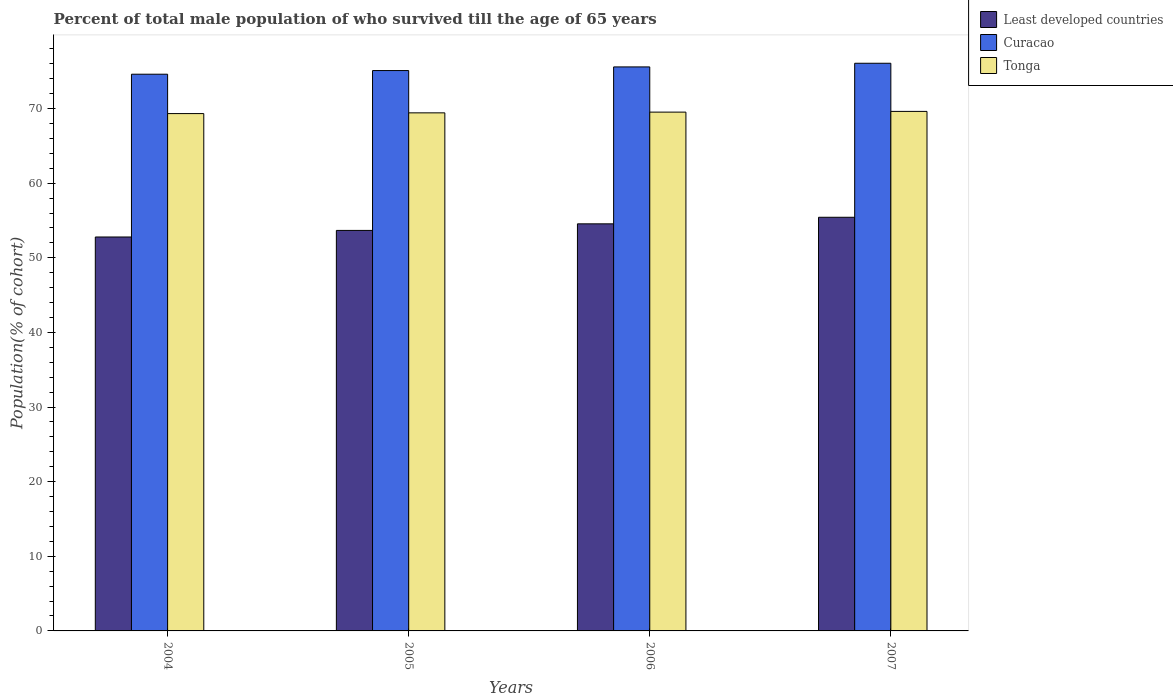How many groups of bars are there?
Ensure brevity in your answer.  4. Are the number of bars per tick equal to the number of legend labels?
Give a very brief answer. Yes. Are the number of bars on each tick of the X-axis equal?
Offer a very short reply. Yes. What is the percentage of total male population who survived till the age of 65 years in Tonga in 2006?
Offer a terse response. 69.53. Across all years, what is the maximum percentage of total male population who survived till the age of 65 years in Curacao?
Your response must be concise. 76.08. Across all years, what is the minimum percentage of total male population who survived till the age of 65 years in Tonga?
Ensure brevity in your answer.  69.33. In which year was the percentage of total male population who survived till the age of 65 years in Least developed countries minimum?
Offer a terse response. 2004. What is the total percentage of total male population who survived till the age of 65 years in Tonga in the graph?
Offer a very short reply. 277.92. What is the difference between the percentage of total male population who survived till the age of 65 years in Tonga in 2005 and that in 2007?
Your answer should be compact. -0.2. What is the difference between the percentage of total male population who survived till the age of 65 years in Tonga in 2006 and the percentage of total male population who survived till the age of 65 years in Least developed countries in 2004?
Give a very brief answer. 16.73. What is the average percentage of total male population who survived till the age of 65 years in Curacao per year?
Provide a short and direct response. 75.34. In the year 2005, what is the difference between the percentage of total male population who survived till the age of 65 years in Curacao and percentage of total male population who survived till the age of 65 years in Least developed countries?
Provide a succinct answer. 21.42. What is the ratio of the percentage of total male population who survived till the age of 65 years in Curacao in 2005 to that in 2007?
Keep it short and to the point. 0.99. Is the percentage of total male population who survived till the age of 65 years in Curacao in 2004 less than that in 2005?
Your response must be concise. Yes. What is the difference between the highest and the second highest percentage of total male population who survived till the age of 65 years in Curacao?
Give a very brief answer. 0.49. What is the difference between the highest and the lowest percentage of total male population who survived till the age of 65 years in Curacao?
Offer a terse response. 1.47. In how many years, is the percentage of total male population who survived till the age of 65 years in Tonga greater than the average percentage of total male population who survived till the age of 65 years in Tonga taken over all years?
Keep it short and to the point. 2. Is the sum of the percentage of total male population who survived till the age of 65 years in Least developed countries in 2004 and 2007 greater than the maximum percentage of total male population who survived till the age of 65 years in Curacao across all years?
Keep it short and to the point. Yes. What does the 2nd bar from the left in 2006 represents?
Make the answer very short. Curacao. What does the 2nd bar from the right in 2007 represents?
Provide a succinct answer. Curacao. How many bars are there?
Provide a short and direct response. 12. What is the difference between two consecutive major ticks on the Y-axis?
Your response must be concise. 10. Are the values on the major ticks of Y-axis written in scientific E-notation?
Offer a terse response. No. What is the title of the graph?
Provide a short and direct response. Percent of total male population of who survived till the age of 65 years. Does "Hungary" appear as one of the legend labels in the graph?
Ensure brevity in your answer.  No. What is the label or title of the Y-axis?
Offer a terse response. Population(% of cohort). What is the Population(% of cohort) in Least developed countries in 2004?
Offer a terse response. 52.8. What is the Population(% of cohort) of Curacao in 2004?
Your answer should be compact. 74.61. What is the Population(% of cohort) of Tonga in 2004?
Your answer should be compact. 69.33. What is the Population(% of cohort) in Least developed countries in 2005?
Make the answer very short. 53.68. What is the Population(% of cohort) in Curacao in 2005?
Keep it short and to the point. 75.1. What is the Population(% of cohort) in Tonga in 2005?
Your answer should be compact. 69.43. What is the Population(% of cohort) in Least developed countries in 2006?
Offer a very short reply. 54.56. What is the Population(% of cohort) of Curacao in 2006?
Ensure brevity in your answer.  75.59. What is the Population(% of cohort) in Tonga in 2006?
Give a very brief answer. 69.53. What is the Population(% of cohort) of Least developed countries in 2007?
Your response must be concise. 55.44. What is the Population(% of cohort) in Curacao in 2007?
Ensure brevity in your answer.  76.08. What is the Population(% of cohort) of Tonga in 2007?
Your answer should be very brief. 69.63. Across all years, what is the maximum Population(% of cohort) of Least developed countries?
Give a very brief answer. 55.44. Across all years, what is the maximum Population(% of cohort) in Curacao?
Your response must be concise. 76.08. Across all years, what is the maximum Population(% of cohort) in Tonga?
Your answer should be compact. 69.63. Across all years, what is the minimum Population(% of cohort) in Least developed countries?
Ensure brevity in your answer.  52.8. Across all years, what is the minimum Population(% of cohort) in Curacao?
Ensure brevity in your answer.  74.61. Across all years, what is the minimum Population(% of cohort) of Tonga?
Offer a very short reply. 69.33. What is the total Population(% of cohort) in Least developed countries in the graph?
Give a very brief answer. 216.46. What is the total Population(% of cohort) in Curacao in the graph?
Provide a short and direct response. 301.38. What is the total Population(% of cohort) of Tonga in the graph?
Make the answer very short. 277.92. What is the difference between the Population(% of cohort) of Least developed countries in 2004 and that in 2005?
Provide a succinct answer. -0.88. What is the difference between the Population(% of cohort) of Curacao in 2004 and that in 2005?
Offer a terse response. -0.49. What is the difference between the Population(% of cohort) of Tonga in 2004 and that in 2005?
Offer a very short reply. -0.1. What is the difference between the Population(% of cohort) in Least developed countries in 2004 and that in 2006?
Your response must be concise. -1.76. What is the difference between the Population(% of cohort) in Curacao in 2004 and that in 2006?
Your answer should be very brief. -0.98. What is the difference between the Population(% of cohort) of Tonga in 2004 and that in 2006?
Your answer should be compact. -0.2. What is the difference between the Population(% of cohort) of Least developed countries in 2004 and that in 2007?
Provide a short and direct response. -2.64. What is the difference between the Population(% of cohort) of Curacao in 2004 and that in 2007?
Keep it short and to the point. -1.47. What is the difference between the Population(% of cohort) of Tonga in 2004 and that in 2007?
Keep it short and to the point. -0.29. What is the difference between the Population(% of cohort) of Least developed countries in 2005 and that in 2006?
Ensure brevity in your answer.  -0.88. What is the difference between the Population(% of cohort) in Curacao in 2005 and that in 2006?
Offer a terse response. -0.49. What is the difference between the Population(% of cohort) in Tonga in 2005 and that in 2006?
Offer a terse response. -0.1. What is the difference between the Population(% of cohort) in Least developed countries in 2005 and that in 2007?
Give a very brief answer. -1.76. What is the difference between the Population(% of cohort) of Curacao in 2005 and that in 2007?
Your answer should be very brief. -0.98. What is the difference between the Population(% of cohort) of Tonga in 2005 and that in 2007?
Provide a succinct answer. -0.2. What is the difference between the Population(% of cohort) of Least developed countries in 2006 and that in 2007?
Give a very brief answer. -0.88. What is the difference between the Population(% of cohort) in Curacao in 2006 and that in 2007?
Give a very brief answer. -0.49. What is the difference between the Population(% of cohort) in Tonga in 2006 and that in 2007?
Offer a terse response. -0.1. What is the difference between the Population(% of cohort) in Least developed countries in 2004 and the Population(% of cohort) in Curacao in 2005?
Offer a terse response. -22.3. What is the difference between the Population(% of cohort) in Least developed countries in 2004 and the Population(% of cohort) in Tonga in 2005?
Your answer should be very brief. -16.64. What is the difference between the Population(% of cohort) in Curacao in 2004 and the Population(% of cohort) in Tonga in 2005?
Keep it short and to the point. 5.18. What is the difference between the Population(% of cohort) in Least developed countries in 2004 and the Population(% of cohort) in Curacao in 2006?
Offer a terse response. -22.79. What is the difference between the Population(% of cohort) in Least developed countries in 2004 and the Population(% of cohort) in Tonga in 2006?
Offer a very short reply. -16.73. What is the difference between the Population(% of cohort) of Curacao in 2004 and the Population(% of cohort) of Tonga in 2006?
Ensure brevity in your answer.  5.08. What is the difference between the Population(% of cohort) in Least developed countries in 2004 and the Population(% of cohort) in Curacao in 2007?
Offer a very short reply. -23.28. What is the difference between the Population(% of cohort) in Least developed countries in 2004 and the Population(% of cohort) in Tonga in 2007?
Your answer should be very brief. -16.83. What is the difference between the Population(% of cohort) in Curacao in 2004 and the Population(% of cohort) in Tonga in 2007?
Ensure brevity in your answer.  4.98. What is the difference between the Population(% of cohort) of Least developed countries in 2005 and the Population(% of cohort) of Curacao in 2006?
Your answer should be compact. -21.91. What is the difference between the Population(% of cohort) of Least developed countries in 2005 and the Population(% of cohort) of Tonga in 2006?
Provide a short and direct response. -15.85. What is the difference between the Population(% of cohort) of Curacao in 2005 and the Population(% of cohort) of Tonga in 2006?
Keep it short and to the point. 5.57. What is the difference between the Population(% of cohort) in Least developed countries in 2005 and the Population(% of cohort) in Curacao in 2007?
Provide a short and direct response. -22.4. What is the difference between the Population(% of cohort) of Least developed countries in 2005 and the Population(% of cohort) of Tonga in 2007?
Give a very brief answer. -15.95. What is the difference between the Population(% of cohort) of Curacao in 2005 and the Population(% of cohort) of Tonga in 2007?
Ensure brevity in your answer.  5.47. What is the difference between the Population(% of cohort) in Least developed countries in 2006 and the Population(% of cohort) in Curacao in 2007?
Provide a succinct answer. -21.52. What is the difference between the Population(% of cohort) in Least developed countries in 2006 and the Population(% of cohort) in Tonga in 2007?
Offer a very short reply. -15.07. What is the difference between the Population(% of cohort) of Curacao in 2006 and the Population(% of cohort) of Tonga in 2007?
Provide a succinct answer. 5.96. What is the average Population(% of cohort) of Least developed countries per year?
Ensure brevity in your answer.  54.12. What is the average Population(% of cohort) of Curacao per year?
Make the answer very short. 75.34. What is the average Population(% of cohort) in Tonga per year?
Your answer should be compact. 69.48. In the year 2004, what is the difference between the Population(% of cohort) in Least developed countries and Population(% of cohort) in Curacao?
Keep it short and to the point. -21.82. In the year 2004, what is the difference between the Population(% of cohort) in Least developed countries and Population(% of cohort) in Tonga?
Offer a very short reply. -16.54. In the year 2004, what is the difference between the Population(% of cohort) in Curacao and Population(% of cohort) in Tonga?
Give a very brief answer. 5.28. In the year 2005, what is the difference between the Population(% of cohort) in Least developed countries and Population(% of cohort) in Curacao?
Provide a short and direct response. -21.42. In the year 2005, what is the difference between the Population(% of cohort) in Least developed countries and Population(% of cohort) in Tonga?
Provide a short and direct response. -15.76. In the year 2005, what is the difference between the Population(% of cohort) in Curacao and Population(% of cohort) in Tonga?
Offer a terse response. 5.67. In the year 2006, what is the difference between the Population(% of cohort) in Least developed countries and Population(% of cohort) in Curacao?
Your response must be concise. -21.03. In the year 2006, what is the difference between the Population(% of cohort) in Least developed countries and Population(% of cohort) in Tonga?
Your answer should be very brief. -14.97. In the year 2006, what is the difference between the Population(% of cohort) in Curacao and Population(% of cohort) in Tonga?
Give a very brief answer. 6.06. In the year 2007, what is the difference between the Population(% of cohort) in Least developed countries and Population(% of cohort) in Curacao?
Provide a short and direct response. -20.64. In the year 2007, what is the difference between the Population(% of cohort) in Least developed countries and Population(% of cohort) in Tonga?
Your response must be concise. -14.19. In the year 2007, what is the difference between the Population(% of cohort) in Curacao and Population(% of cohort) in Tonga?
Provide a succinct answer. 6.45. What is the ratio of the Population(% of cohort) of Least developed countries in 2004 to that in 2005?
Your answer should be compact. 0.98. What is the ratio of the Population(% of cohort) of Tonga in 2004 to that in 2005?
Your answer should be compact. 1. What is the ratio of the Population(% of cohort) in Curacao in 2004 to that in 2006?
Ensure brevity in your answer.  0.99. What is the ratio of the Population(% of cohort) of Tonga in 2004 to that in 2006?
Ensure brevity in your answer.  1. What is the ratio of the Population(% of cohort) of Least developed countries in 2004 to that in 2007?
Provide a short and direct response. 0.95. What is the ratio of the Population(% of cohort) of Curacao in 2004 to that in 2007?
Keep it short and to the point. 0.98. What is the ratio of the Population(% of cohort) in Least developed countries in 2005 to that in 2006?
Your response must be concise. 0.98. What is the ratio of the Population(% of cohort) in Least developed countries in 2005 to that in 2007?
Make the answer very short. 0.97. What is the ratio of the Population(% of cohort) of Curacao in 2005 to that in 2007?
Keep it short and to the point. 0.99. What is the ratio of the Population(% of cohort) of Tonga in 2005 to that in 2007?
Your answer should be compact. 1. What is the ratio of the Population(% of cohort) in Least developed countries in 2006 to that in 2007?
Your answer should be very brief. 0.98. What is the ratio of the Population(% of cohort) of Tonga in 2006 to that in 2007?
Offer a very short reply. 1. What is the difference between the highest and the second highest Population(% of cohort) in Least developed countries?
Your answer should be very brief. 0.88. What is the difference between the highest and the second highest Population(% of cohort) of Curacao?
Keep it short and to the point. 0.49. What is the difference between the highest and the second highest Population(% of cohort) of Tonga?
Offer a terse response. 0.1. What is the difference between the highest and the lowest Population(% of cohort) in Least developed countries?
Give a very brief answer. 2.64. What is the difference between the highest and the lowest Population(% of cohort) of Curacao?
Make the answer very short. 1.47. What is the difference between the highest and the lowest Population(% of cohort) in Tonga?
Ensure brevity in your answer.  0.29. 